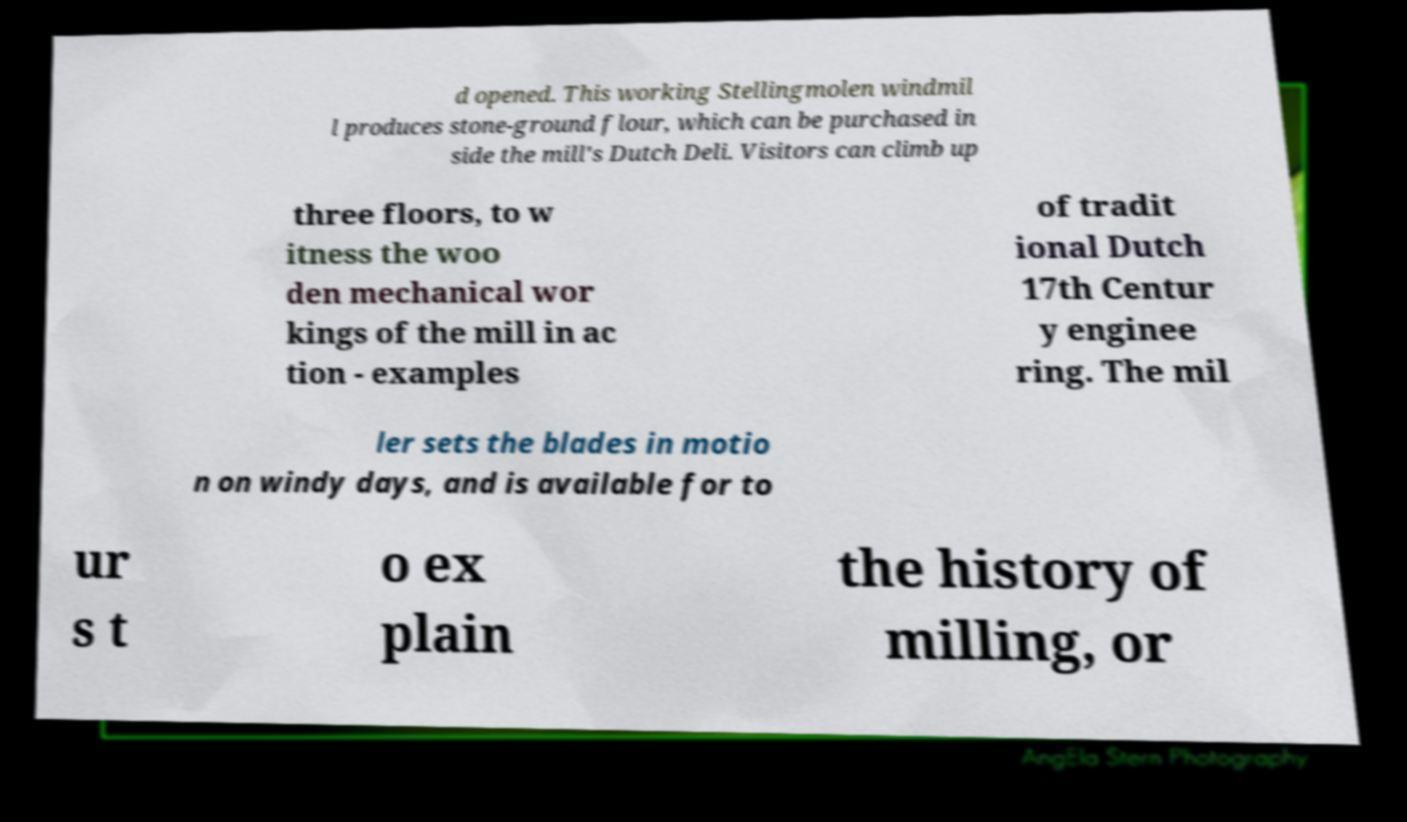Could you extract and type out the text from this image? d opened. This working Stellingmolen windmil l produces stone-ground flour, which can be purchased in side the mill's Dutch Deli. Visitors can climb up three floors, to w itness the woo den mechanical wor kings of the mill in ac tion - examples of tradit ional Dutch 17th Centur y enginee ring. The mil ler sets the blades in motio n on windy days, and is available for to ur s t o ex plain the history of milling, or 